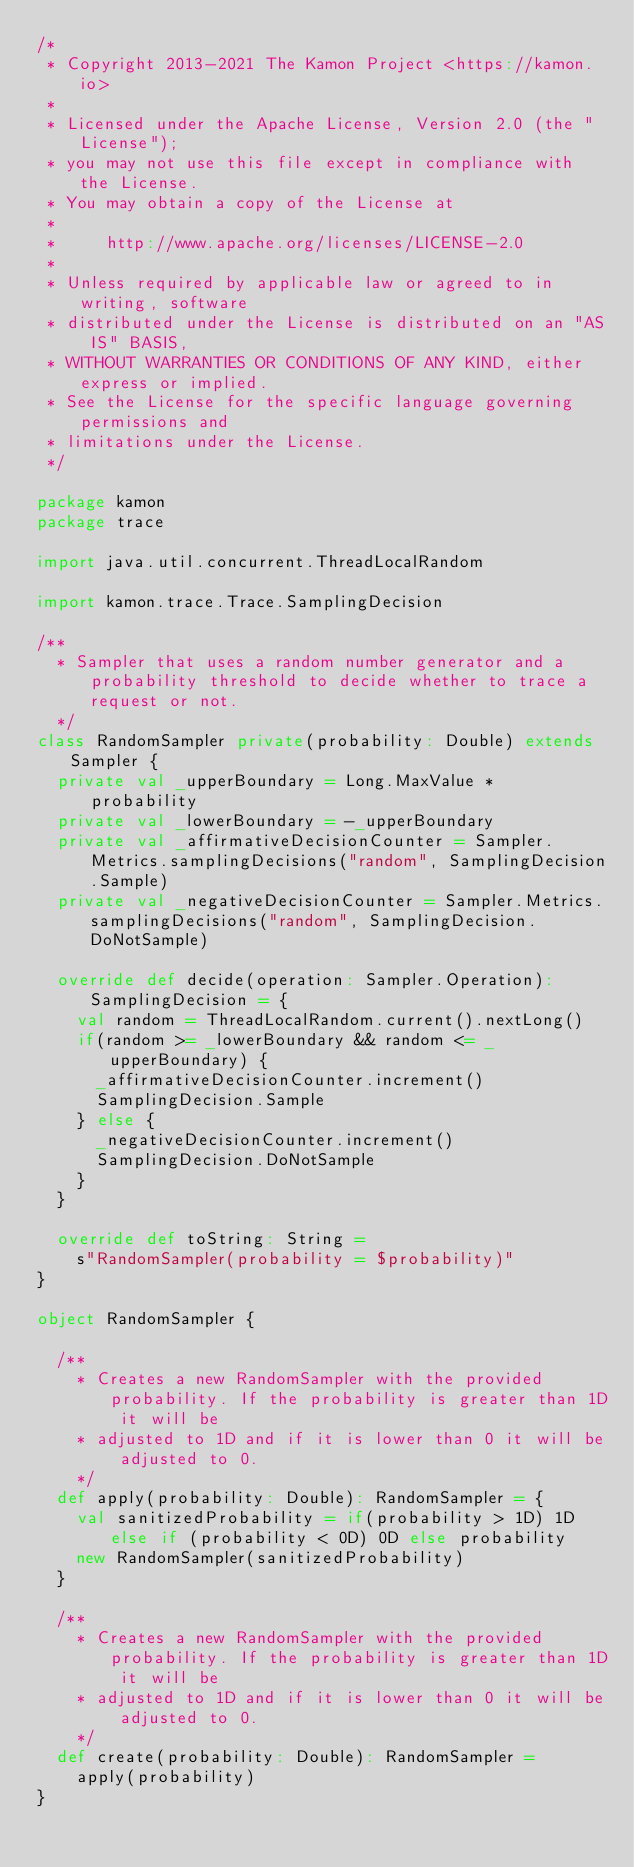Convert code to text. <code><loc_0><loc_0><loc_500><loc_500><_Scala_>/*
 * Copyright 2013-2021 The Kamon Project <https://kamon.io>
 *
 * Licensed under the Apache License, Version 2.0 (the "License");
 * you may not use this file except in compliance with the License.
 * You may obtain a copy of the License at
 *
 *     http://www.apache.org/licenses/LICENSE-2.0
 *
 * Unless required by applicable law or agreed to in writing, software
 * distributed under the License is distributed on an "AS IS" BASIS,
 * WITHOUT WARRANTIES OR CONDITIONS OF ANY KIND, either express or implied.
 * See the License for the specific language governing permissions and
 * limitations under the License.
 */

package kamon
package trace

import java.util.concurrent.ThreadLocalRandom

import kamon.trace.Trace.SamplingDecision

/**
  * Sampler that uses a random number generator and a probability threshold to decide whether to trace a request or not.
  */
class RandomSampler private(probability: Double) extends Sampler {
  private val _upperBoundary = Long.MaxValue * probability
  private val _lowerBoundary = -_upperBoundary
  private val _affirmativeDecisionCounter = Sampler.Metrics.samplingDecisions("random", SamplingDecision.Sample)
  private val _negativeDecisionCounter = Sampler.Metrics.samplingDecisions("random", SamplingDecision.DoNotSample)

  override def decide(operation: Sampler.Operation): SamplingDecision = {
    val random = ThreadLocalRandom.current().nextLong()
    if(random >= _lowerBoundary && random <= _upperBoundary) {
      _affirmativeDecisionCounter.increment()
      SamplingDecision.Sample
    } else {
      _negativeDecisionCounter.increment()
      SamplingDecision.DoNotSample
    }
  }

  override def toString: String =
    s"RandomSampler(probability = $probability)"
}

object RandomSampler {

  /**
    * Creates a new RandomSampler with the provided probability. If the probability is greater than 1D it will be
    * adjusted to 1D and if it is lower than 0 it will be adjusted to 0.
    */
  def apply(probability: Double): RandomSampler = {
    val sanitizedProbability = if(probability > 1D) 1D else if (probability < 0D) 0D else probability
    new RandomSampler(sanitizedProbability)
  }

  /**
    * Creates a new RandomSampler with the provided probability. If the probability is greater than 1D it will be
    * adjusted to 1D and if it is lower than 0 it will be adjusted to 0.
    */
  def create(probability: Double): RandomSampler =
    apply(probability)
}
</code> 